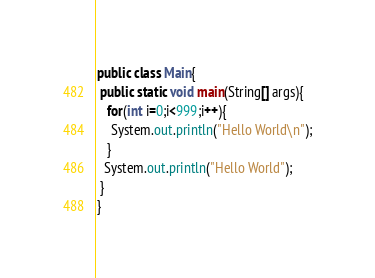Convert code to text. <code><loc_0><loc_0><loc_500><loc_500><_Java_>public class Main{
 public static void main(String[] args){
   for(int i=0;i<999;i++){
    System.out.println("Hello World\n");
   }
  System.out.println("Hello World");
 }
}</code> 